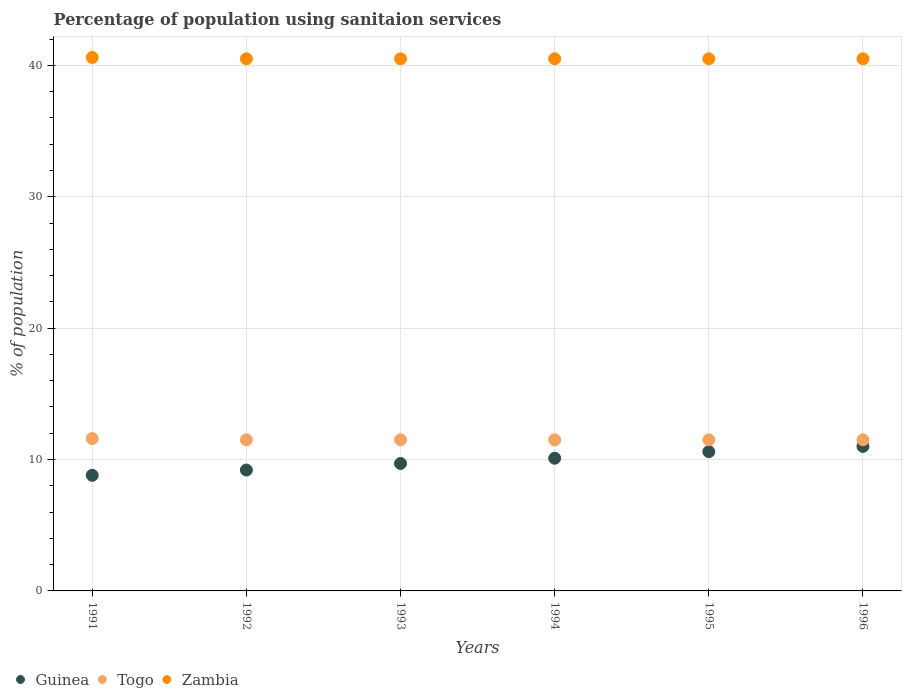What is the percentage of population using sanitaion services in Zambia in 1995?
Offer a terse response. 40.5. Across all years, what is the minimum percentage of population using sanitaion services in Zambia?
Your response must be concise. 40.5. What is the total percentage of population using sanitaion services in Guinea in the graph?
Your answer should be compact. 59.4. What is the difference between the percentage of population using sanitaion services in Zambia in 1991 and that in 1996?
Make the answer very short. 0.1. What is the difference between the percentage of population using sanitaion services in Togo in 1991 and the percentage of population using sanitaion services in Zambia in 1995?
Offer a terse response. -28.9. What is the average percentage of population using sanitaion services in Zambia per year?
Provide a succinct answer. 40.52. In the year 1996, what is the difference between the percentage of population using sanitaion services in Guinea and percentage of population using sanitaion services in Zambia?
Your answer should be very brief. -29.5. What is the ratio of the percentage of population using sanitaion services in Zambia in 1993 to that in 1996?
Make the answer very short. 1. Is the percentage of population using sanitaion services in Guinea in 1992 less than that in 1995?
Provide a succinct answer. Yes. Is the difference between the percentage of population using sanitaion services in Guinea in 1992 and 1994 greater than the difference between the percentage of population using sanitaion services in Zambia in 1992 and 1994?
Offer a terse response. No. What is the difference between the highest and the second highest percentage of population using sanitaion services in Togo?
Your answer should be very brief. 0.1. What is the difference between the highest and the lowest percentage of population using sanitaion services in Guinea?
Keep it short and to the point. 2.2. Is the sum of the percentage of population using sanitaion services in Togo in 1995 and 1996 greater than the maximum percentage of population using sanitaion services in Guinea across all years?
Keep it short and to the point. Yes. Is it the case that in every year, the sum of the percentage of population using sanitaion services in Zambia and percentage of population using sanitaion services in Togo  is greater than the percentage of population using sanitaion services in Guinea?
Give a very brief answer. Yes. Does the percentage of population using sanitaion services in Togo monotonically increase over the years?
Offer a terse response. No. Is the percentage of population using sanitaion services in Guinea strictly less than the percentage of population using sanitaion services in Zambia over the years?
Make the answer very short. Yes. How many years are there in the graph?
Your response must be concise. 6. What is the difference between two consecutive major ticks on the Y-axis?
Your answer should be compact. 10. Are the values on the major ticks of Y-axis written in scientific E-notation?
Your answer should be very brief. No. Does the graph contain any zero values?
Keep it short and to the point. No. Does the graph contain grids?
Provide a short and direct response. Yes. How many legend labels are there?
Your answer should be compact. 3. What is the title of the graph?
Provide a short and direct response. Percentage of population using sanitaion services. What is the label or title of the Y-axis?
Your answer should be compact. % of population. What is the % of population in Guinea in 1991?
Keep it short and to the point. 8.8. What is the % of population of Togo in 1991?
Offer a very short reply. 11.6. What is the % of population in Zambia in 1991?
Make the answer very short. 40.6. What is the % of population in Guinea in 1992?
Offer a very short reply. 9.2. What is the % of population in Zambia in 1992?
Your answer should be very brief. 40.5. What is the % of population in Togo in 1993?
Provide a short and direct response. 11.5. What is the % of population in Zambia in 1993?
Ensure brevity in your answer.  40.5. What is the % of population of Togo in 1994?
Offer a terse response. 11.5. What is the % of population of Zambia in 1994?
Provide a short and direct response. 40.5. What is the % of population in Guinea in 1995?
Keep it short and to the point. 10.6. What is the % of population of Togo in 1995?
Your answer should be very brief. 11.5. What is the % of population in Zambia in 1995?
Keep it short and to the point. 40.5. What is the % of population in Zambia in 1996?
Offer a terse response. 40.5. Across all years, what is the maximum % of population in Togo?
Make the answer very short. 11.6. Across all years, what is the maximum % of population of Zambia?
Keep it short and to the point. 40.6. Across all years, what is the minimum % of population of Togo?
Offer a very short reply. 11.5. Across all years, what is the minimum % of population of Zambia?
Make the answer very short. 40.5. What is the total % of population in Guinea in the graph?
Your response must be concise. 59.4. What is the total % of population of Togo in the graph?
Offer a very short reply. 69.1. What is the total % of population in Zambia in the graph?
Your answer should be compact. 243.1. What is the difference between the % of population in Guinea in 1991 and that in 1992?
Your answer should be very brief. -0.4. What is the difference between the % of population in Guinea in 1991 and that in 1993?
Provide a short and direct response. -0.9. What is the difference between the % of population of Togo in 1991 and that in 1993?
Your answer should be very brief. 0.1. What is the difference between the % of population of Zambia in 1991 and that in 1993?
Offer a terse response. 0.1. What is the difference between the % of population in Guinea in 1991 and that in 1994?
Your response must be concise. -1.3. What is the difference between the % of population of Zambia in 1991 and that in 1994?
Offer a terse response. 0.1. What is the difference between the % of population of Guinea in 1991 and that in 1995?
Make the answer very short. -1.8. What is the difference between the % of population in Togo in 1991 and that in 1995?
Your response must be concise. 0.1. What is the difference between the % of population of Zambia in 1991 and that in 1995?
Provide a succinct answer. 0.1. What is the difference between the % of population in Guinea in 1991 and that in 1996?
Offer a terse response. -2.2. What is the difference between the % of population in Togo in 1991 and that in 1996?
Your answer should be compact. 0.1. What is the difference between the % of population in Togo in 1992 and that in 1994?
Your answer should be very brief. 0. What is the difference between the % of population in Togo in 1992 and that in 1995?
Offer a very short reply. 0. What is the difference between the % of population of Zambia in 1992 and that in 1995?
Your answer should be very brief. 0. What is the difference between the % of population of Togo in 1992 and that in 1996?
Provide a succinct answer. 0. What is the difference between the % of population of Zambia in 1992 and that in 1996?
Offer a terse response. 0. What is the difference between the % of population in Togo in 1993 and that in 1994?
Keep it short and to the point. 0. What is the difference between the % of population in Guinea in 1993 and that in 1995?
Your answer should be compact. -0.9. What is the difference between the % of population of Togo in 1993 and that in 1995?
Provide a succinct answer. 0. What is the difference between the % of population in Guinea in 1993 and that in 1996?
Your answer should be very brief. -1.3. What is the difference between the % of population of Zambia in 1993 and that in 1996?
Offer a very short reply. 0. What is the difference between the % of population in Guinea in 1994 and that in 1995?
Your answer should be very brief. -0.5. What is the difference between the % of population of Togo in 1994 and that in 1995?
Give a very brief answer. 0. What is the difference between the % of population in Zambia in 1994 and that in 1995?
Give a very brief answer. 0. What is the difference between the % of population in Guinea in 1994 and that in 1996?
Your answer should be compact. -0.9. What is the difference between the % of population of Zambia in 1994 and that in 1996?
Offer a very short reply. 0. What is the difference between the % of population in Togo in 1995 and that in 1996?
Provide a short and direct response. 0. What is the difference between the % of population of Zambia in 1995 and that in 1996?
Your answer should be compact. 0. What is the difference between the % of population of Guinea in 1991 and the % of population of Togo in 1992?
Your answer should be very brief. -2.7. What is the difference between the % of population of Guinea in 1991 and the % of population of Zambia in 1992?
Provide a short and direct response. -31.7. What is the difference between the % of population of Togo in 1991 and the % of population of Zambia in 1992?
Your answer should be compact. -28.9. What is the difference between the % of population in Guinea in 1991 and the % of population in Togo in 1993?
Keep it short and to the point. -2.7. What is the difference between the % of population of Guinea in 1991 and the % of population of Zambia in 1993?
Provide a succinct answer. -31.7. What is the difference between the % of population in Togo in 1991 and the % of population in Zambia in 1993?
Give a very brief answer. -28.9. What is the difference between the % of population in Guinea in 1991 and the % of population in Togo in 1994?
Offer a very short reply. -2.7. What is the difference between the % of population in Guinea in 1991 and the % of population in Zambia in 1994?
Keep it short and to the point. -31.7. What is the difference between the % of population in Togo in 1991 and the % of population in Zambia in 1994?
Make the answer very short. -28.9. What is the difference between the % of population of Guinea in 1991 and the % of population of Togo in 1995?
Offer a very short reply. -2.7. What is the difference between the % of population of Guinea in 1991 and the % of population of Zambia in 1995?
Your answer should be very brief. -31.7. What is the difference between the % of population in Togo in 1991 and the % of population in Zambia in 1995?
Make the answer very short. -28.9. What is the difference between the % of population in Guinea in 1991 and the % of population in Togo in 1996?
Offer a very short reply. -2.7. What is the difference between the % of population of Guinea in 1991 and the % of population of Zambia in 1996?
Keep it short and to the point. -31.7. What is the difference between the % of population of Togo in 1991 and the % of population of Zambia in 1996?
Your answer should be compact. -28.9. What is the difference between the % of population of Guinea in 1992 and the % of population of Zambia in 1993?
Your response must be concise. -31.3. What is the difference between the % of population of Togo in 1992 and the % of population of Zambia in 1993?
Offer a terse response. -29. What is the difference between the % of population in Guinea in 1992 and the % of population in Zambia in 1994?
Give a very brief answer. -31.3. What is the difference between the % of population of Guinea in 1992 and the % of population of Zambia in 1995?
Your answer should be compact. -31.3. What is the difference between the % of population in Togo in 1992 and the % of population in Zambia in 1995?
Make the answer very short. -29. What is the difference between the % of population of Guinea in 1992 and the % of population of Togo in 1996?
Provide a short and direct response. -2.3. What is the difference between the % of population of Guinea in 1992 and the % of population of Zambia in 1996?
Make the answer very short. -31.3. What is the difference between the % of population of Togo in 1992 and the % of population of Zambia in 1996?
Keep it short and to the point. -29. What is the difference between the % of population in Guinea in 1993 and the % of population in Zambia in 1994?
Keep it short and to the point. -30.8. What is the difference between the % of population of Togo in 1993 and the % of population of Zambia in 1994?
Offer a very short reply. -29. What is the difference between the % of population in Guinea in 1993 and the % of population in Zambia in 1995?
Your answer should be compact. -30.8. What is the difference between the % of population in Guinea in 1993 and the % of population in Togo in 1996?
Your answer should be compact. -1.8. What is the difference between the % of population in Guinea in 1993 and the % of population in Zambia in 1996?
Make the answer very short. -30.8. What is the difference between the % of population in Togo in 1993 and the % of population in Zambia in 1996?
Your answer should be very brief. -29. What is the difference between the % of population of Guinea in 1994 and the % of population of Togo in 1995?
Your response must be concise. -1.4. What is the difference between the % of population in Guinea in 1994 and the % of population in Zambia in 1995?
Keep it short and to the point. -30.4. What is the difference between the % of population in Guinea in 1994 and the % of population in Togo in 1996?
Provide a short and direct response. -1.4. What is the difference between the % of population of Guinea in 1994 and the % of population of Zambia in 1996?
Keep it short and to the point. -30.4. What is the difference between the % of population in Guinea in 1995 and the % of population in Togo in 1996?
Offer a very short reply. -0.9. What is the difference between the % of population in Guinea in 1995 and the % of population in Zambia in 1996?
Give a very brief answer. -29.9. What is the average % of population of Guinea per year?
Make the answer very short. 9.9. What is the average % of population in Togo per year?
Provide a short and direct response. 11.52. What is the average % of population of Zambia per year?
Your response must be concise. 40.52. In the year 1991, what is the difference between the % of population of Guinea and % of population of Zambia?
Give a very brief answer. -31.8. In the year 1992, what is the difference between the % of population in Guinea and % of population in Togo?
Your response must be concise. -2.3. In the year 1992, what is the difference between the % of population in Guinea and % of population in Zambia?
Offer a terse response. -31.3. In the year 1993, what is the difference between the % of population in Guinea and % of population in Togo?
Provide a succinct answer. -1.8. In the year 1993, what is the difference between the % of population in Guinea and % of population in Zambia?
Provide a succinct answer. -30.8. In the year 1993, what is the difference between the % of population in Togo and % of population in Zambia?
Make the answer very short. -29. In the year 1994, what is the difference between the % of population of Guinea and % of population of Zambia?
Provide a short and direct response. -30.4. In the year 1994, what is the difference between the % of population of Togo and % of population of Zambia?
Offer a terse response. -29. In the year 1995, what is the difference between the % of population in Guinea and % of population in Zambia?
Give a very brief answer. -29.9. In the year 1995, what is the difference between the % of population in Togo and % of population in Zambia?
Offer a terse response. -29. In the year 1996, what is the difference between the % of population in Guinea and % of population in Togo?
Provide a succinct answer. -0.5. In the year 1996, what is the difference between the % of population of Guinea and % of population of Zambia?
Your response must be concise. -29.5. In the year 1996, what is the difference between the % of population in Togo and % of population in Zambia?
Ensure brevity in your answer.  -29. What is the ratio of the % of population in Guinea in 1991 to that in 1992?
Make the answer very short. 0.96. What is the ratio of the % of population of Togo in 1991 to that in 1992?
Provide a short and direct response. 1.01. What is the ratio of the % of population of Guinea in 1991 to that in 1993?
Your answer should be very brief. 0.91. What is the ratio of the % of population in Togo in 1991 to that in 1993?
Your answer should be compact. 1.01. What is the ratio of the % of population in Guinea in 1991 to that in 1994?
Your response must be concise. 0.87. What is the ratio of the % of population of Togo in 1991 to that in 1994?
Ensure brevity in your answer.  1.01. What is the ratio of the % of population of Zambia in 1991 to that in 1994?
Offer a very short reply. 1. What is the ratio of the % of population of Guinea in 1991 to that in 1995?
Give a very brief answer. 0.83. What is the ratio of the % of population in Togo in 1991 to that in 1995?
Keep it short and to the point. 1.01. What is the ratio of the % of population in Guinea in 1991 to that in 1996?
Your answer should be compact. 0.8. What is the ratio of the % of population of Togo in 1991 to that in 1996?
Offer a very short reply. 1.01. What is the ratio of the % of population of Guinea in 1992 to that in 1993?
Provide a short and direct response. 0.95. What is the ratio of the % of population in Guinea in 1992 to that in 1994?
Provide a succinct answer. 0.91. What is the ratio of the % of population of Guinea in 1992 to that in 1995?
Provide a short and direct response. 0.87. What is the ratio of the % of population of Togo in 1992 to that in 1995?
Your answer should be very brief. 1. What is the ratio of the % of population of Guinea in 1992 to that in 1996?
Offer a very short reply. 0.84. What is the ratio of the % of population in Zambia in 1992 to that in 1996?
Offer a very short reply. 1. What is the ratio of the % of population in Guinea in 1993 to that in 1994?
Offer a very short reply. 0.96. What is the ratio of the % of population in Togo in 1993 to that in 1994?
Make the answer very short. 1. What is the ratio of the % of population of Guinea in 1993 to that in 1995?
Keep it short and to the point. 0.92. What is the ratio of the % of population in Zambia in 1993 to that in 1995?
Provide a succinct answer. 1. What is the ratio of the % of population in Guinea in 1993 to that in 1996?
Ensure brevity in your answer.  0.88. What is the ratio of the % of population in Guinea in 1994 to that in 1995?
Provide a short and direct response. 0.95. What is the ratio of the % of population of Zambia in 1994 to that in 1995?
Make the answer very short. 1. What is the ratio of the % of population of Guinea in 1994 to that in 1996?
Offer a very short reply. 0.92. What is the ratio of the % of population of Zambia in 1994 to that in 1996?
Your answer should be very brief. 1. What is the ratio of the % of population in Guinea in 1995 to that in 1996?
Your answer should be very brief. 0.96. What is the ratio of the % of population in Zambia in 1995 to that in 1996?
Offer a very short reply. 1. What is the difference between the highest and the lowest % of population in Togo?
Keep it short and to the point. 0.1. What is the difference between the highest and the lowest % of population in Zambia?
Ensure brevity in your answer.  0.1. 